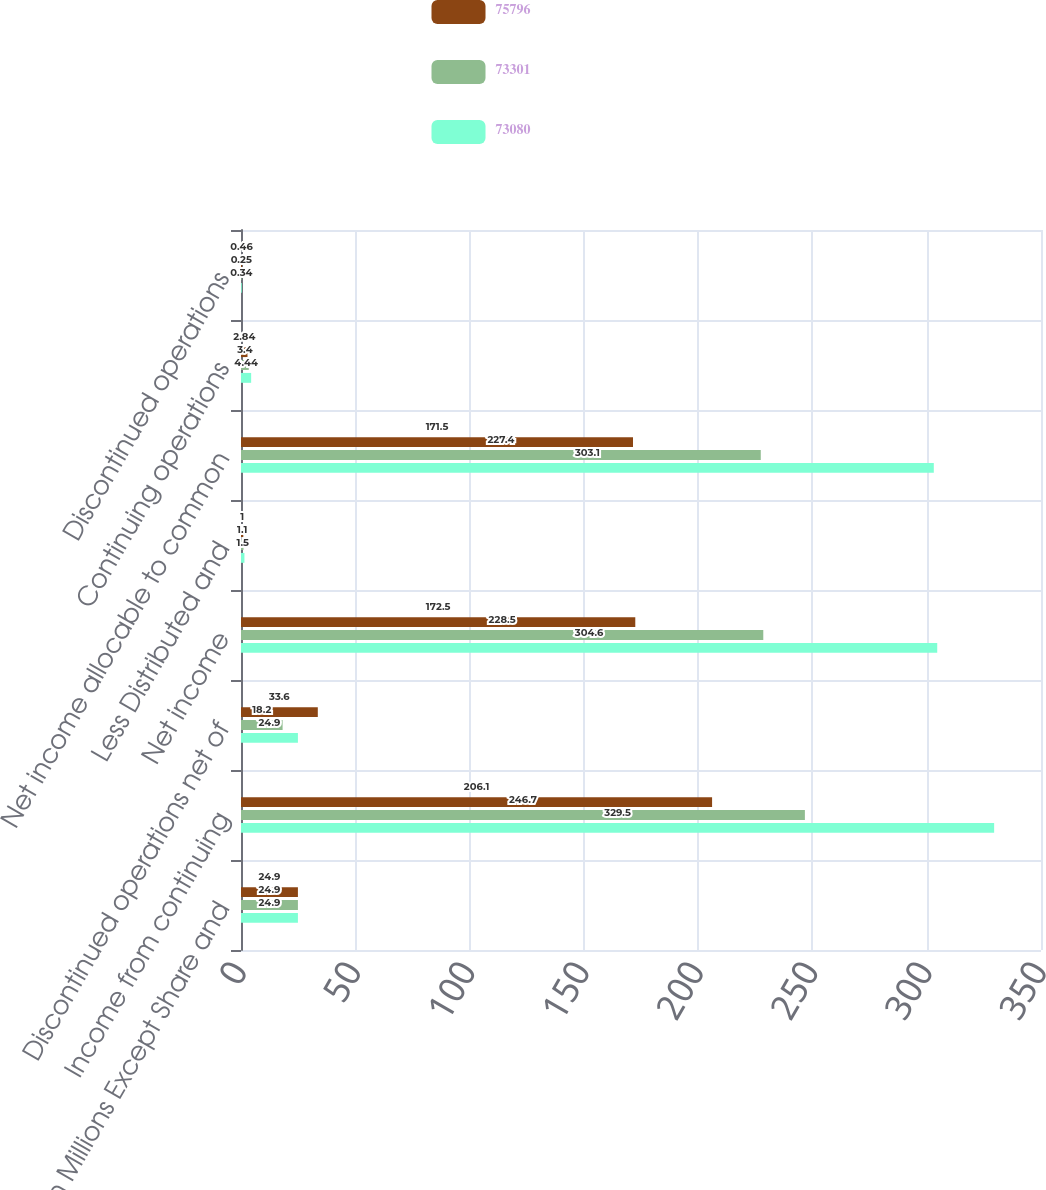Convert chart to OTSL. <chart><loc_0><loc_0><loc_500><loc_500><stacked_bar_chart><ecel><fcel>(in Millions Except Share and<fcel>Income from continuing<fcel>Discontinued operations net of<fcel>Net income<fcel>Less Distributed and<fcel>Net income allocable to common<fcel>Continuing operations<fcel>Discontinued operations<nl><fcel>75796<fcel>24.9<fcel>206.1<fcel>33.6<fcel>172.5<fcel>1<fcel>171.5<fcel>2.84<fcel>0.46<nl><fcel>73301<fcel>24.9<fcel>246.7<fcel>18.2<fcel>228.5<fcel>1.1<fcel>227.4<fcel>3.4<fcel>0.25<nl><fcel>73080<fcel>24.9<fcel>329.5<fcel>24.9<fcel>304.6<fcel>1.5<fcel>303.1<fcel>4.44<fcel>0.34<nl></chart> 